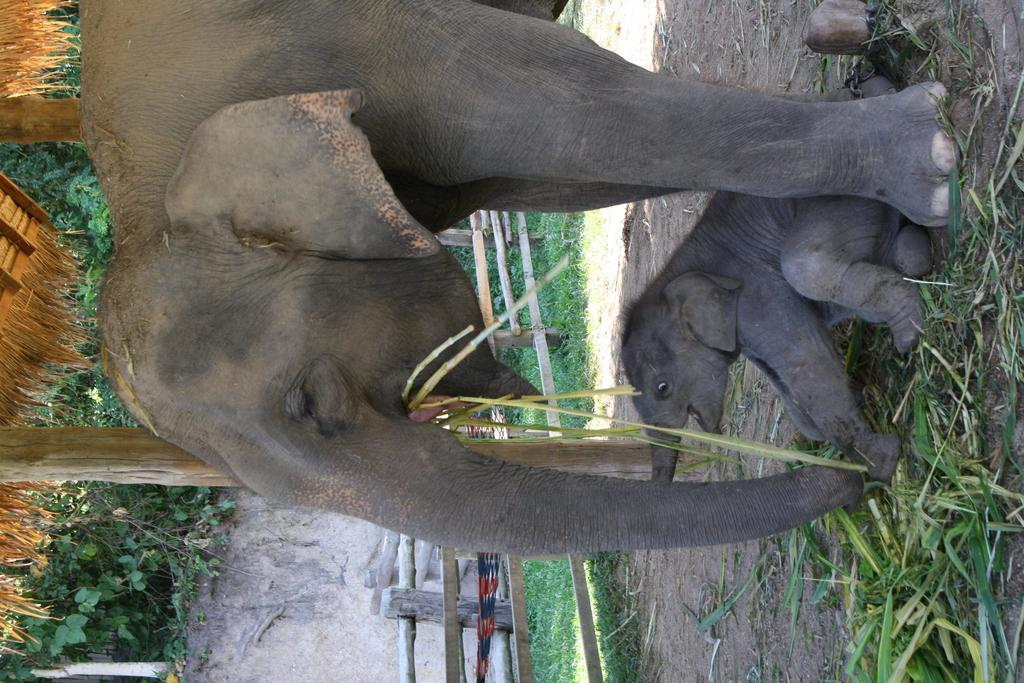What is the main subject of the image? There is a huge elephant in the image. What is the elephant doing in the image? The elephant is eating grass. Can you describe the baby elephant in the image? The baby elephant is sitting on the ground. What can be seen in the background of the image? There are green plants visible in the background of the image. How many statements are written on the baseball in the image? There is no baseball present in the image. What is the amount of water in the image? There is no reference to water in the image; it features an elephant eating grass and a baby elephant sitting on the ground. 